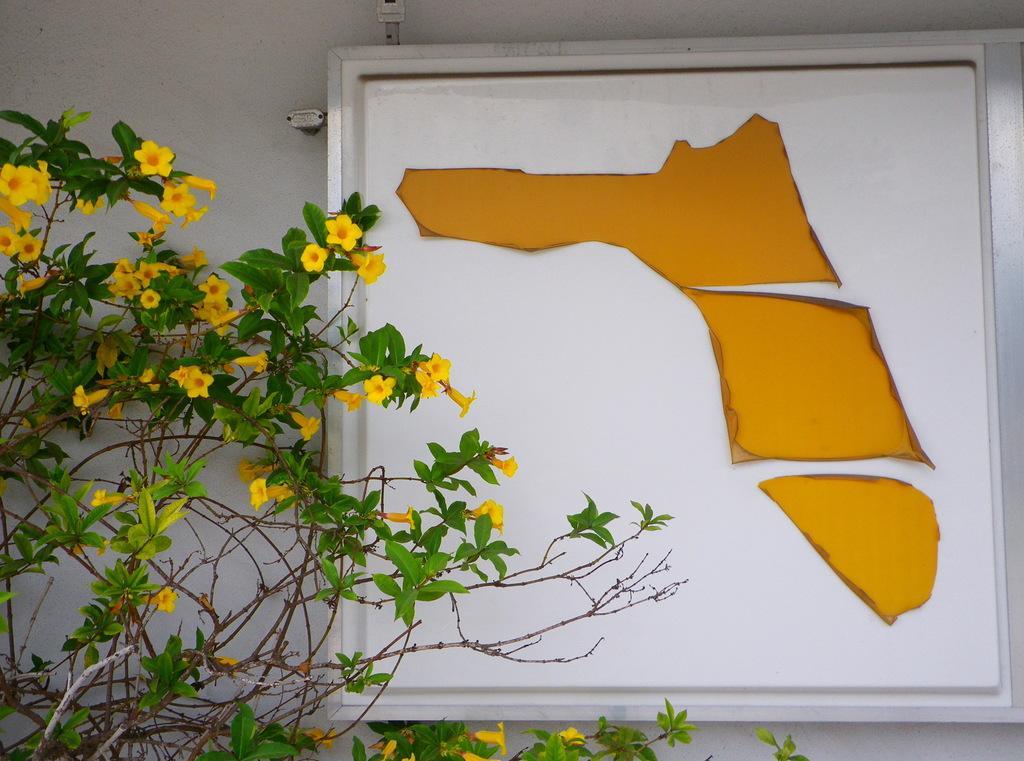Please provide a concise description of this image. In this image I can see the plants in front, on which there are yellow color flowers and I can see a white board on which there are yellow color papers. In the background I can see the wall. 